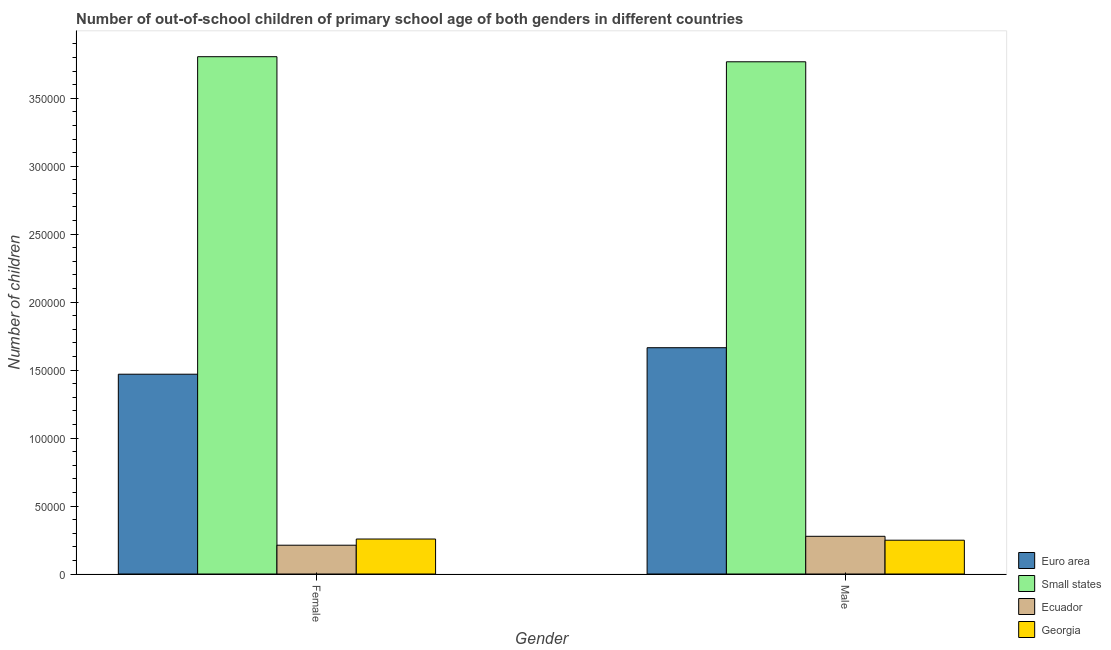How many different coloured bars are there?
Offer a very short reply. 4. How many groups of bars are there?
Offer a very short reply. 2. Are the number of bars on each tick of the X-axis equal?
Provide a succinct answer. Yes. How many bars are there on the 2nd tick from the right?
Provide a short and direct response. 4. What is the label of the 2nd group of bars from the left?
Keep it short and to the point. Male. What is the number of male out-of-school students in Small states?
Make the answer very short. 3.77e+05. Across all countries, what is the maximum number of female out-of-school students?
Make the answer very short. 3.81e+05. Across all countries, what is the minimum number of female out-of-school students?
Offer a terse response. 2.12e+04. In which country was the number of female out-of-school students maximum?
Provide a short and direct response. Small states. In which country was the number of female out-of-school students minimum?
Provide a short and direct response. Ecuador. What is the total number of female out-of-school students in the graph?
Your answer should be compact. 5.74e+05. What is the difference between the number of female out-of-school students in Small states and that in Ecuador?
Provide a succinct answer. 3.59e+05. What is the difference between the number of female out-of-school students in Euro area and the number of male out-of-school students in Georgia?
Offer a very short reply. 1.22e+05. What is the average number of male out-of-school students per country?
Give a very brief answer. 1.49e+05. What is the difference between the number of female out-of-school students and number of male out-of-school students in Ecuador?
Offer a very short reply. -6554. In how many countries, is the number of male out-of-school students greater than 190000 ?
Your response must be concise. 1. What is the ratio of the number of male out-of-school students in Ecuador to that in Georgia?
Offer a terse response. 1.12. In how many countries, is the number of female out-of-school students greater than the average number of female out-of-school students taken over all countries?
Offer a terse response. 2. What does the 4th bar from the left in Male represents?
Keep it short and to the point. Georgia. What does the 1st bar from the right in Male represents?
Keep it short and to the point. Georgia. What is the difference between two consecutive major ticks on the Y-axis?
Ensure brevity in your answer.  5.00e+04. Are the values on the major ticks of Y-axis written in scientific E-notation?
Your response must be concise. No. Does the graph contain any zero values?
Keep it short and to the point. No. Does the graph contain grids?
Offer a terse response. No. Where does the legend appear in the graph?
Provide a short and direct response. Bottom right. What is the title of the graph?
Offer a very short reply. Number of out-of-school children of primary school age of both genders in different countries. Does "OECD members" appear as one of the legend labels in the graph?
Keep it short and to the point. No. What is the label or title of the Y-axis?
Provide a succinct answer. Number of children. What is the Number of children of Euro area in Female?
Your answer should be compact. 1.47e+05. What is the Number of children in Small states in Female?
Offer a very short reply. 3.81e+05. What is the Number of children in Ecuador in Female?
Make the answer very short. 2.12e+04. What is the Number of children in Georgia in Female?
Make the answer very short. 2.57e+04. What is the Number of children in Euro area in Male?
Your answer should be very brief. 1.66e+05. What is the Number of children in Small states in Male?
Your answer should be compact. 3.77e+05. What is the Number of children in Ecuador in Male?
Provide a succinct answer. 2.77e+04. What is the Number of children in Georgia in Male?
Provide a succinct answer. 2.49e+04. Across all Gender, what is the maximum Number of children in Euro area?
Your response must be concise. 1.66e+05. Across all Gender, what is the maximum Number of children of Small states?
Keep it short and to the point. 3.81e+05. Across all Gender, what is the maximum Number of children of Ecuador?
Ensure brevity in your answer.  2.77e+04. Across all Gender, what is the maximum Number of children of Georgia?
Your answer should be very brief. 2.57e+04. Across all Gender, what is the minimum Number of children in Euro area?
Keep it short and to the point. 1.47e+05. Across all Gender, what is the minimum Number of children in Small states?
Your answer should be very brief. 3.77e+05. Across all Gender, what is the minimum Number of children in Ecuador?
Offer a terse response. 2.12e+04. Across all Gender, what is the minimum Number of children of Georgia?
Your response must be concise. 2.49e+04. What is the total Number of children in Euro area in the graph?
Your response must be concise. 3.13e+05. What is the total Number of children in Small states in the graph?
Your answer should be compact. 7.57e+05. What is the total Number of children of Ecuador in the graph?
Your response must be concise. 4.89e+04. What is the total Number of children in Georgia in the graph?
Your answer should be compact. 5.06e+04. What is the difference between the Number of children of Euro area in Female and that in Male?
Your answer should be compact. -1.95e+04. What is the difference between the Number of children in Small states in Female and that in Male?
Offer a very short reply. 3750. What is the difference between the Number of children of Ecuador in Female and that in Male?
Make the answer very short. -6554. What is the difference between the Number of children in Georgia in Female and that in Male?
Make the answer very short. 874. What is the difference between the Number of children of Euro area in Female and the Number of children of Small states in Male?
Offer a terse response. -2.30e+05. What is the difference between the Number of children of Euro area in Female and the Number of children of Ecuador in Male?
Your answer should be very brief. 1.19e+05. What is the difference between the Number of children in Euro area in Female and the Number of children in Georgia in Male?
Ensure brevity in your answer.  1.22e+05. What is the difference between the Number of children of Small states in Female and the Number of children of Ecuador in Male?
Keep it short and to the point. 3.53e+05. What is the difference between the Number of children in Small states in Female and the Number of children in Georgia in Male?
Ensure brevity in your answer.  3.56e+05. What is the difference between the Number of children in Ecuador in Female and the Number of children in Georgia in Male?
Make the answer very short. -3681. What is the average Number of children in Euro area per Gender?
Your answer should be very brief. 1.57e+05. What is the average Number of children of Small states per Gender?
Provide a short and direct response. 3.79e+05. What is the average Number of children of Ecuador per Gender?
Keep it short and to the point. 2.45e+04. What is the average Number of children of Georgia per Gender?
Keep it short and to the point. 2.53e+04. What is the difference between the Number of children in Euro area and Number of children in Small states in Female?
Give a very brief answer. -2.34e+05. What is the difference between the Number of children of Euro area and Number of children of Ecuador in Female?
Ensure brevity in your answer.  1.26e+05. What is the difference between the Number of children of Euro area and Number of children of Georgia in Female?
Offer a very short reply. 1.21e+05. What is the difference between the Number of children of Small states and Number of children of Ecuador in Female?
Your answer should be very brief. 3.59e+05. What is the difference between the Number of children of Small states and Number of children of Georgia in Female?
Your answer should be compact. 3.55e+05. What is the difference between the Number of children in Ecuador and Number of children in Georgia in Female?
Make the answer very short. -4555. What is the difference between the Number of children in Euro area and Number of children in Small states in Male?
Give a very brief answer. -2.10e+05. What is the difference between the Number of children of Euro area and Number of children of Ecuador in Male?
Provide a short and direct response. 1.39e+05. What is the difference between the Number of children in Euro area and Number of children in Georgia in Male?
Keep it short and to the point. 1.42e+05. What is the difference between the Number of children in Small states and Number of children in Ecuador in Male?
Ensure brevity in your answer.  3.49e+05. What is the difference between the Number of children in Small states and Number of children in Georgia in Male?
Provide a succinct answer. 3.52e+05. What is the difference between the Number of children in Ecuador and Number of children in Georgia in Male?
Your response must be concise. 2873. What is the ratio of the Number of children of Euro area in Female to that in Male?
Give a very brief answer. 0.88. What is the ratio of the Number of children in Ecuador in Female to that in Male?
Provide a succinct answer. 0.76. What is the ratio of the Number of children in Georgia in Female to that in Male?
Your answer should be very brief. 1.04. What is the difference between the highest and the second highest Number of children of Euro area?
Your answer should be compact. 1.95e+04. What is the difference between the highest and the second highest Number of children in Small states?
Your answer should be very brief. 3750. What is the difference between the highest and the second highest Number of children of Ecuador?
Your answer should be very brief. 6554. What is the difference between the highest and the second highest Number of children in Georgia?
Make the answer very short. 874. What is the difference between the highest and the lowest Number of children of Euro area?
Your response must be concise. 1.95e+04. What is the difference between the highest and the lowest Number of children in Small states?
Provide a succinct answer. 3750. What is the difference between the highest and the lowest Number of children of Ecuador?
Ensure brevity in your answer.  6554. What is the difference between the highest and the lowest Number of children in Georgia?
Offer a very short reply. 874. 